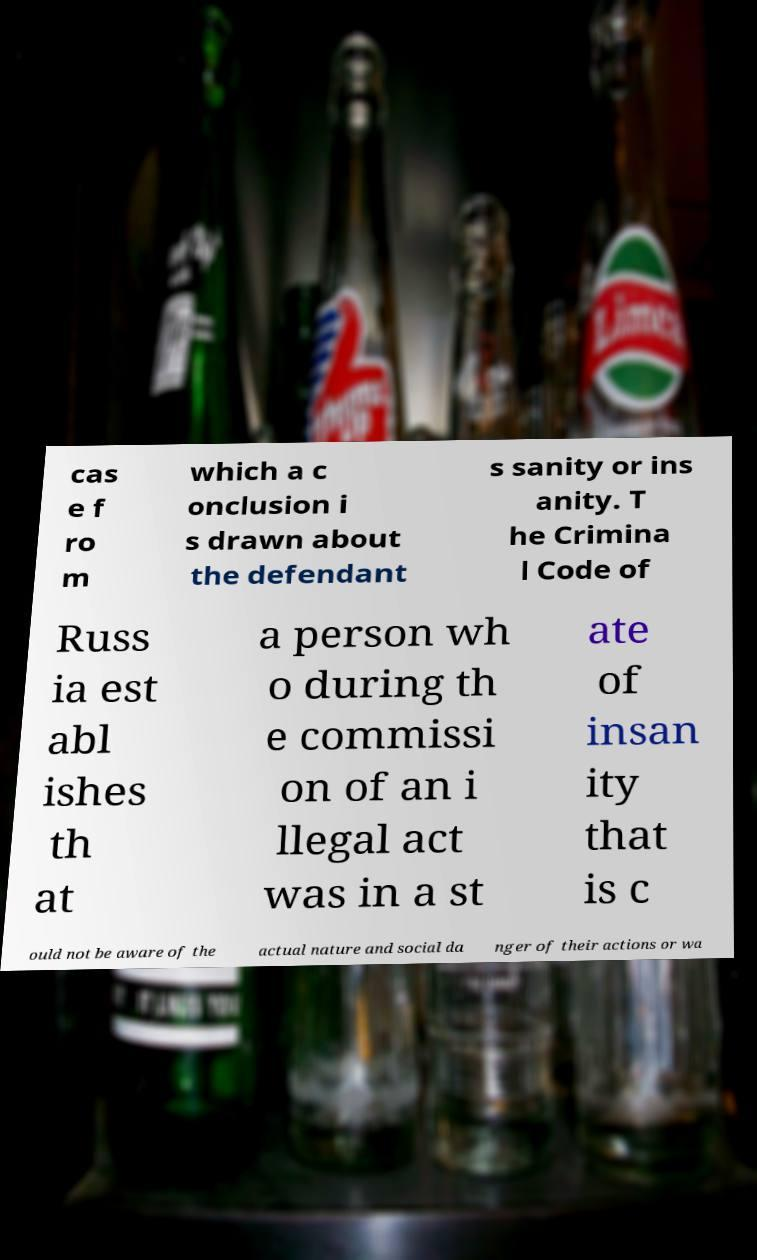What messages or text are displayed in this image? I need them in a readable, typed format. cas e f ro m which a c onclusion i s drawn about the defendant s sanity or ins anity. T he Crimina l Code of Russ ia est abl ishes th at a person wh o during th e commissi on of an i llegal act was in a st ate of insan ity that is c ould not be aware of the actual nature and social da nger of their actions or wa 